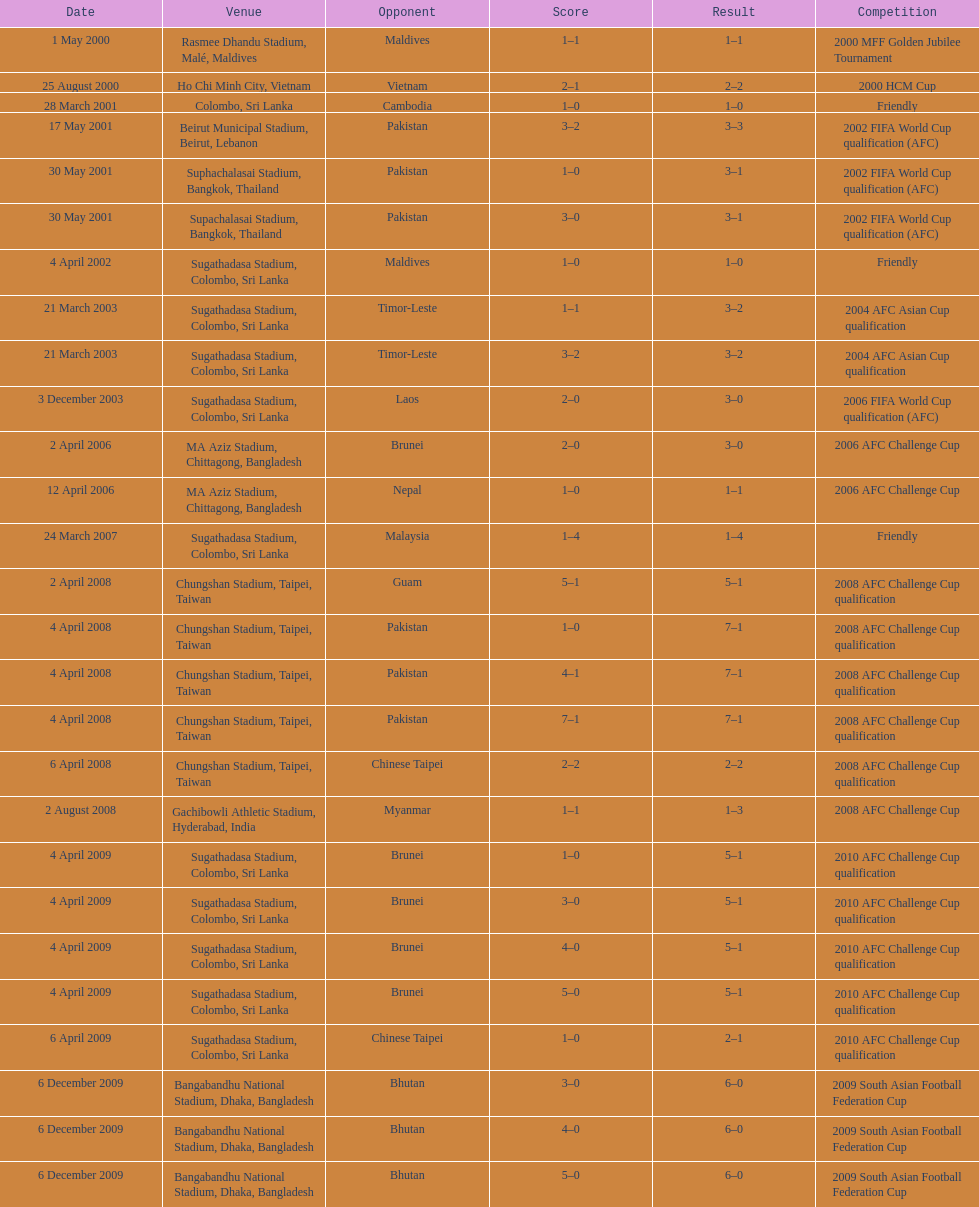Which team did this player face before pakistan on april 4, 2008? Guam. 